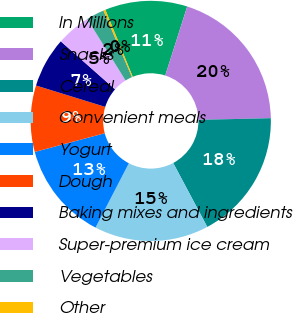Convert chart to OTSL. <chart><loc_0><loc_0><loc_500><loc_500><pie_chart><fcel>In Millions<fcel>Snacks<fcel>Cereal<fcel>Convenient meals<fcel>Yogurt<fcel>Dough<fcel>Baking mixes and ingredients<fcel>Super-premium ice cream<fcel>Vegetables<fcel>Other<nl><fcel>11.08%<fcel>19.73%<fcel>17.57%<fcel>15.4%<fcel>13.24%<fcel>8.92%<fcel>6.76%<fcel>4.6%<fcel>2.43%<fcel>0.27%<nl></chart> 